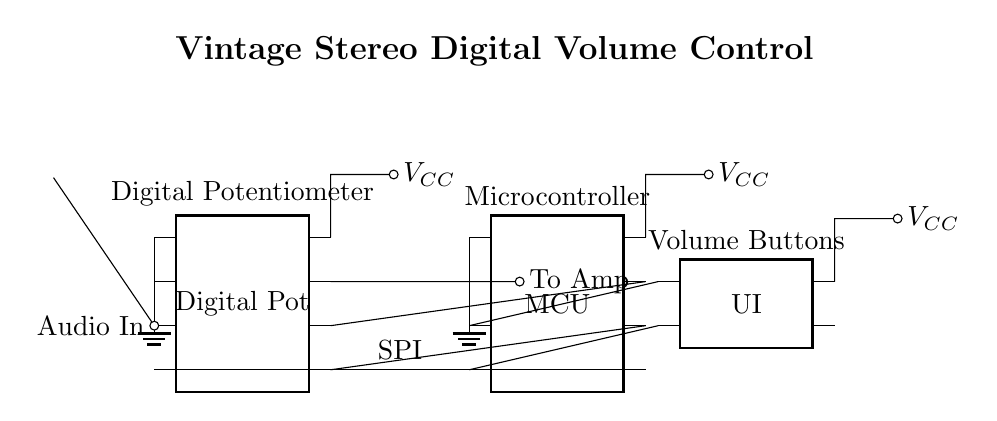What type of circuit is depicted here? The circuit shown is a digital volume control circuit, as indicated by the presence of a digital potentiometer controlled by a microcontroller.
Answer: digital volume control circuit What is the purpose of the microcontroller? The microcontroller manages the digital potentiometer through SPI communication, allowing for volume adjustment based on user inputs from the interface.
Answer: volume control What component connects to the audio input? The audio input connects to the digital potentiometer, which adjusts the audio signal level.
Answer: digital potentiometer How many pins does the digital potentiometer have? The digital potentiometer is shown to have eight pins, which allow for various connections and functionality in the circuit.
Answer: eight What is the voltage supplied to the circuit? The voltage supplied to the circuit is V sub CC, which is indicated next to the power connections of both the digital potentiometer and the microcontroller.
Answer: V sub CC How does the user interface interact with the microcontroller? The user interface interacts with the microcontroller through two pins, where button presses are registered and communicated to adjust the volume setting in the digital potentiometer.
Answer: two pins What type of signals does the digital potentiometer process? The digital potentiometer processes audio signals, specifically the input audio which is then sent to the amplifier after level adjustment.
Answer: audio signals 